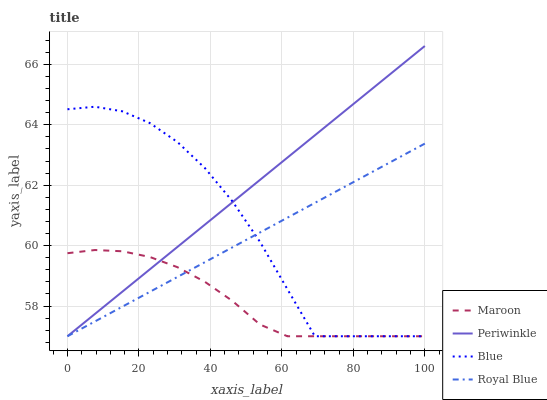Does Maroon have the minimum area under the curve?
Answer yes or no. Yes. Does Periwinkle have the maximum area under the curve?
Answer yes or no. Yes. Does Royal Blue have the minimum area under the curve?
Answer yes or no. No. Does Royal Blue have the maximum area under the curve?
Answer yes or no. No. Is Royal Blue the smoothest?
Answer yes or no. Yes. Is Blue the roughest?
Answer yes or no. Yes. Is Periwinkle the smoothest?
Answer yes or no. No. Is Periwinkle the roughest?
Answer yes or no. No. Does Blue have the lowest value?
Answer yes or no. Yes. Does Periwinkle have the highest value?
Answer yes or no. Yes. Does Royal Blue have the highest value?
Answer yes or no. No. Does Maroon intersect Periwinkle?
Answer yes or no. Yes. Is Maroon less than Periwinkle?
Answer yes or no. No. Is Maroon greater than Periwinkle?
Answer yes or no. No. 